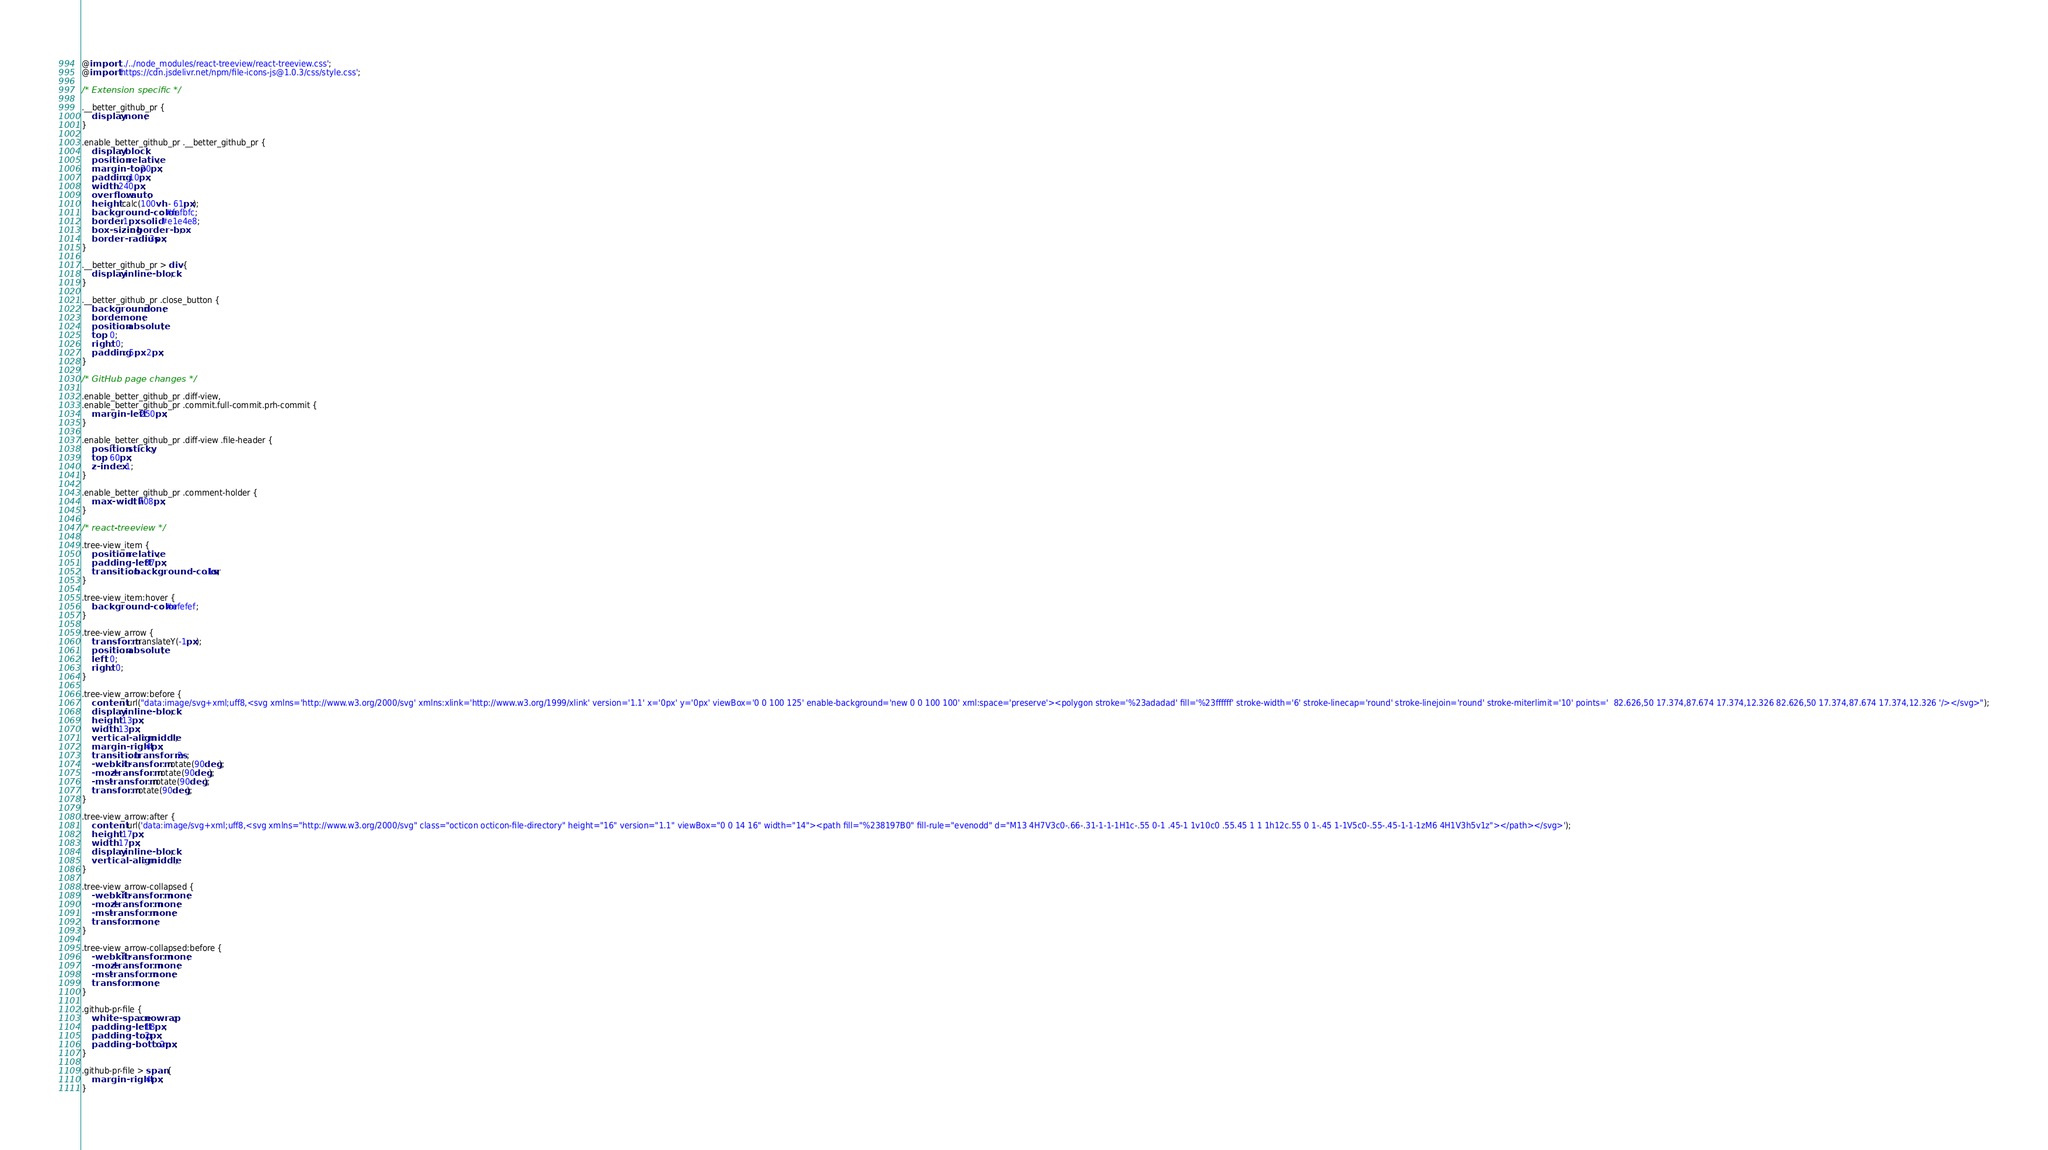Convert code to text. <code><loc_0><loc_0><loc_500><loc_500><_CSS_>@import '../../node_modules/react-treeview/react-treeview.css';
@import 'https://cdn.jsdelivr.net/npm/file-icons-js@1.0.3/css/style.css';

/* Extension specific */

.__better_github_pr {
    display: none;
}

.enable_better_github_pr .__better_github_pr {
    display: block;
    position: relative;
    margin-top: 20px;
    padding: 10px;
    width: 240px;
    overflow: auto;
    height: calc(100vh - 61px);
    background-color: #fafbfc;
    border: 1px solid #e1e4e8;
    box-sizing: border-box;
    border-radius: 3px;
}

.__better_github_pr > div {
    display: inline-block;
}

.__better_github_pr .close_button {
    background: none;
    border: none;
    position: absolute;
    top: 0;
    right: 0;
    padding: 5px 2px;
}

/* GitHub page changes */

.enable_better_github_pr .diff-view,
.enable_better_github_pr .commit.full-commit.prh-commit {
    margin-left: 250px;
}

.enable_better_github_pr .diff-view .file-header {
    position: sticky;
    top: 60px;
    z-index: 1;
}

.enable_better_github_pr .comment-holder {
    max-width: 708px;
}

/* react-treeview */

.tree-view_item {
    position: relative;
    padding-left: 37px;
    transition: background-color .1s;
}

.tree-view_item:hover {
    background-color: #efefef;
}

.tree-view_arrow {
    transform: translateY(-1px);
    position: absolute;
    left: 0;
    right: 0;
}

.tree-view_arrow:before {
    content: url("data:image/svg+xml;uff8,<svg xmlns='http://www.w3.org/2000/svg' xmlns:xlink='http://www.w3.org/1999/xlink' version='1.1' x='0px' y='0px' viewBox='0 0 100 125' enable-background='new 0 0 100 100' xml:space='preserve'><polygon stroke='%23adadad' fill='%23ffffff' stroke-width='6' stroke-linecap='round' stroke-linejoin='round' stroke-miterlimit='10' points='  82.626,50 17.374,87.674 17.374,12.326 82.626,50 17.374,87.674 17.374,12.326 '/></svg>");
    display: inline-block;
    height: 13px;
    width: 13px;
    vertical-align: middle;
    margin-right: 4px;
    transition: transform .2s;
    -webkit-transform: rotate(90deg);
    -moz-transform: rotate(90deg);
    -ms-transform: rotate(90deg);
    transform: rotate(90deg);
}

.tree-view_arrow:after {
    content: url('data:image/svg+xml;uff8,<svg xmlns="http://www.w3.org/2000/svg" class="octicon octicon-file-directory" height="16" version="1.1" viewBox="0 0 14 16" width="14"><path fill="%238197B0" fill-rule="evenodd" d="M13 4H7V3c0-.66-.31-1-1-1H1c-.55 0-1 .45-1 1v10c0 .55.45 1 1 1h12c.55 0 1-.45 1-1V5c0-.55-.45-1-1-1zM6 4H1V3h5v1z"></path></svg>');
    height: 17px;
    width: 17px;
    display: inline-block;
    vertical-align: middle;
}

.tree-view_arrow-collapsed {
    -webkit-transform: none;
    -moz-transform: none;
    -ms-transform: none;
    transform: none;
}

.tree-view_arrow-collapsed:before {
    -webkit-transform: none;
    -moz-transform: none;
    -ms-transform: none;
    transform: none;
}

.github-pr-file {
    white-space: nowrap;
    padding-left: 18px;
    padding-top: 2px;
    padding-bottom: 2px;
}

.github-pr-file > span {
    margin-right: 4px;
}
</code> 